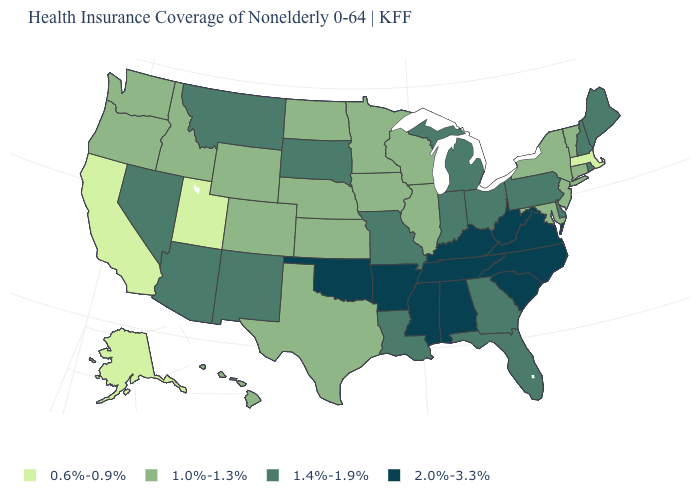Does Alaska have the lowest value in the USA?
Short answer required. Yes. What is the value of North Carolina?
Write a very short answer. 2.0%-3.3%. What is the value of South Carolina?
Be succinct. 2.0%-3.3%. Does South Dakota have the highest value in the MidWest?
Give a very brief answer. Yes. What is the value of Oklahoma?
Keep it brief. 2.0%-3.3%. Name the states that have a value in the range 0.6%-0.9%?
Concise answer only. Alaska, California, Massachusetts, Utah. What is the value of Oregon?
Concise answer only. 1.0%-1.3%. Does Alaska have a lower value than California?
Keep it brief. No. What is the lowest value in states that border Maryland?
Concise answer only. 1.4%-1.9%. What is the lowest value in the USA?
Answer briefly. 0.6%-0.9%. What is the lowest value in the Northeast?
Concise answer only. 0.6%-0.9%. What is the highest value in states that border Oklahoma?
Quick response, please. 2.0%-3.3%. What is the lowest value in the USA?
Answer briefly. 0.6%-0.9%. Among the states that border Delaware , does New Jersey have the highest value?
Keep it brief. No. Does California have the lowest value in the USA?
Concise answer only. Yes. 